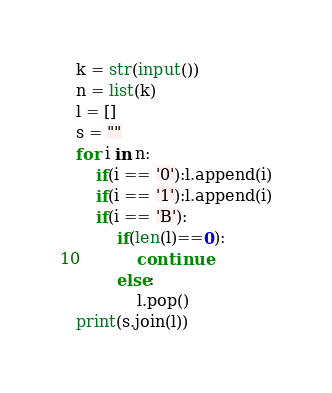Convert code to text. <code><loc_0><loc_0><loc_500><loc_500><_Python_>k = str(input())
n = list(k)
l = []
s = ""
for i in n:
    if(i == '0'):l.append(i)
    if(i == '1'):l.append(i)
    if(i == 'B'):
        if(len(l)==0):
            continue
        else:
            l.pop()
print(s.join(l))</code> 